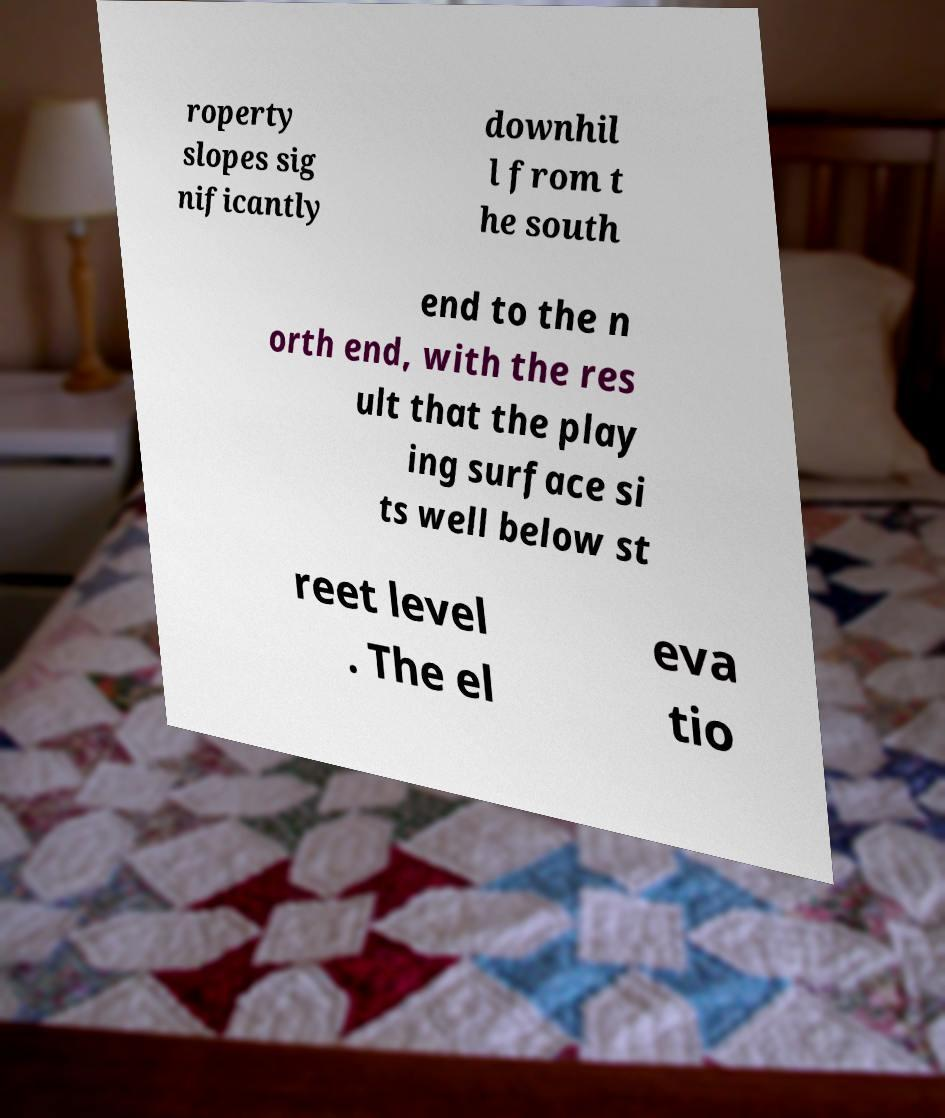Could you extract and type out the text from this image? roperty slopes sig nificantly downhil l from t he south end to the n orth end, with the res ult that the play ing surface si ts well below st reet level . The el eva tio 